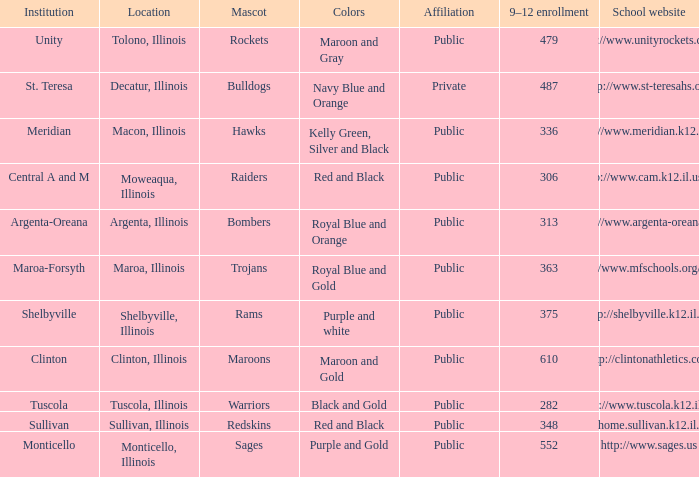What's the name of the city or town of the school that operates the http://www.mfschools.org/high/ website? Maroa-Forsyth. 